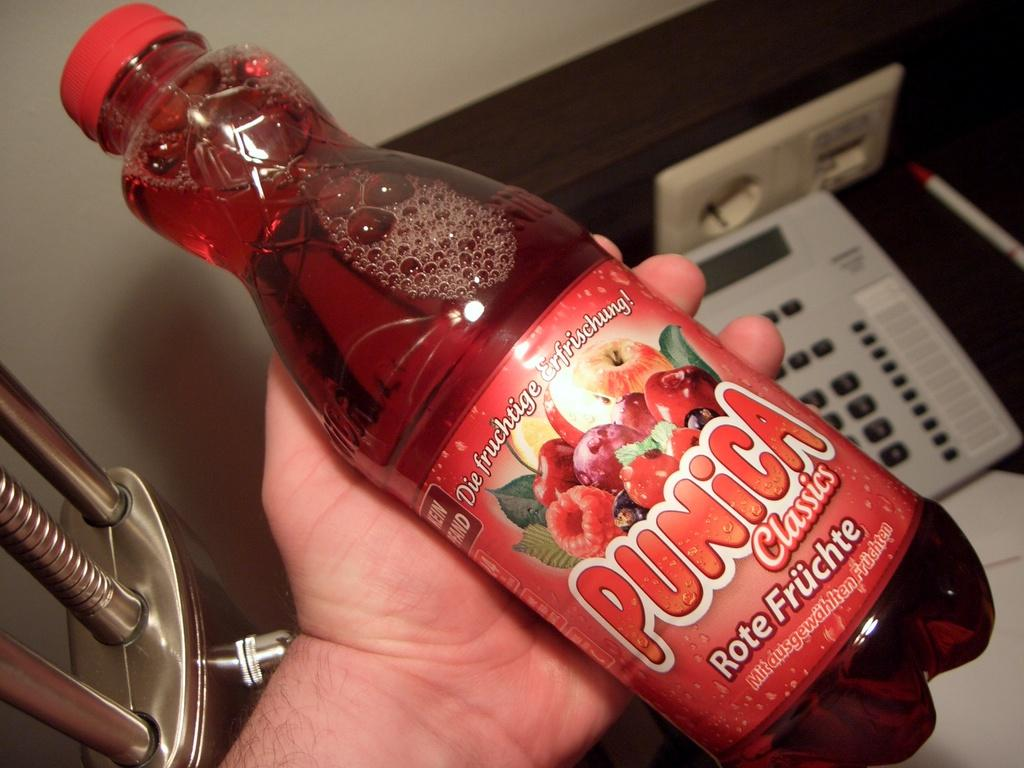Provide a one-sentence caption for the provided image. A hand is holding a bottle of Punica juice. 